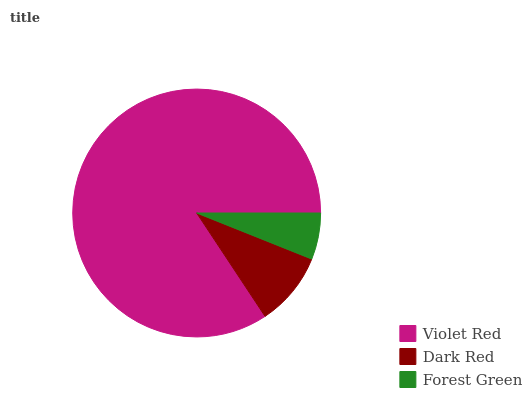Is Forest Green the minimum?
Answer yes or no. Yes. Is Violet Red the maximum?
Answer yes or no. Yes. Is Dark Red the minimum?
Answer yes or no. No. Is Dark Red the maximum?
Answer yes or no. No. Is Violet Red greater than Dark Red?
Answer yes or no. Yes. Is Dark Red less than Violet Red?
Answer yes or no. Yes. Is Dark Red greater than Violet Red?
Answer yes or no. No. Is Violet Red less than Dark Red?
Answer yes or no. No. Is Dark Red the high median?
Answer yes or no. Yes. Is Dark Red the low median?
Answer yes or no. Yes. Is Forest Green the high median?
Answer yes or no. No. Is Violet Red the low median?
Answer yes or no. No. 